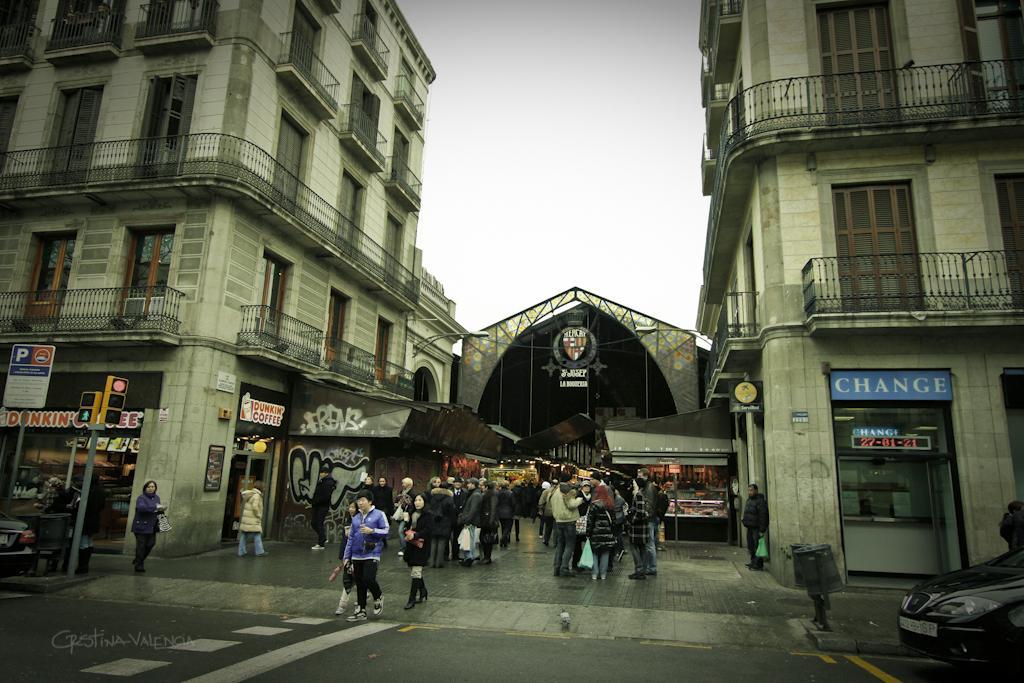Could you give a brief overview of what you see in this image? In this picture there are people and we can see dustbins, vehicles, poles, traffic signals, boards and buildings. In the background of the image we can see the sky. 